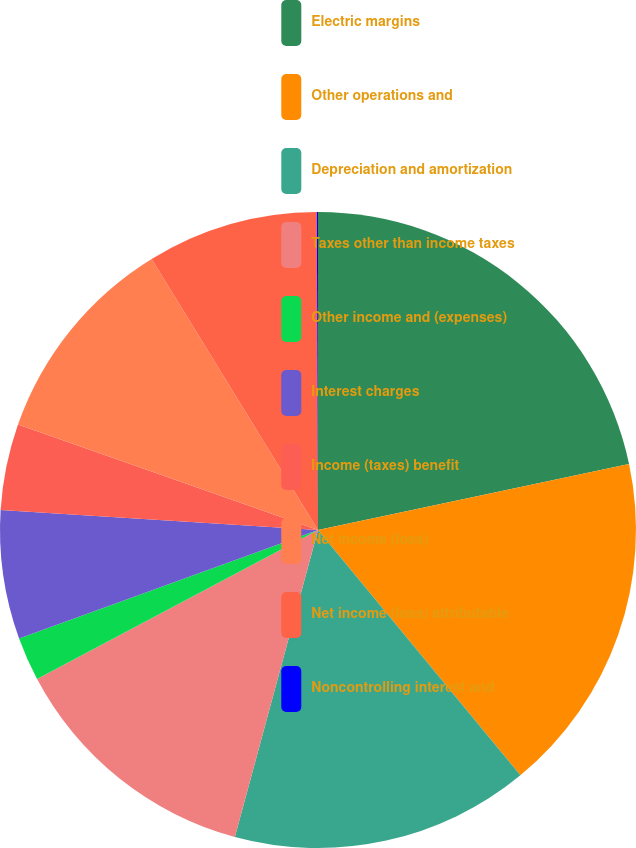Convert chart to OTSL. <chart><loc_0><loc_0><loc_500><loc_500><pie_chart><fcel>Electric margins<fcel>Other operations and<fcel>Depreciation and amortization<fcel>Taxes other than income taxes<fcel>Other income and (expenses)<fcel>Interest charges<fcel>Income (taxes) benefit<fcel>Net income (loss)<fcel>Net income (loss) attributable<fcel>Noncontrolling interest and<nl><fcel>21.67%<fcel>17.35%<fcel>15.19%<fcel>13.03%<fcel>2.22%<fcel>6.54%<fcel>4.38%<fcel>10.86%<fcel>8.7%<fcel>0.06%<nl></chart> 